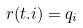Convert formula to latex. <formula><loc_0><loc_0><loc_500><loc_500>r ( t . i ) = q _ { i }</formula> 